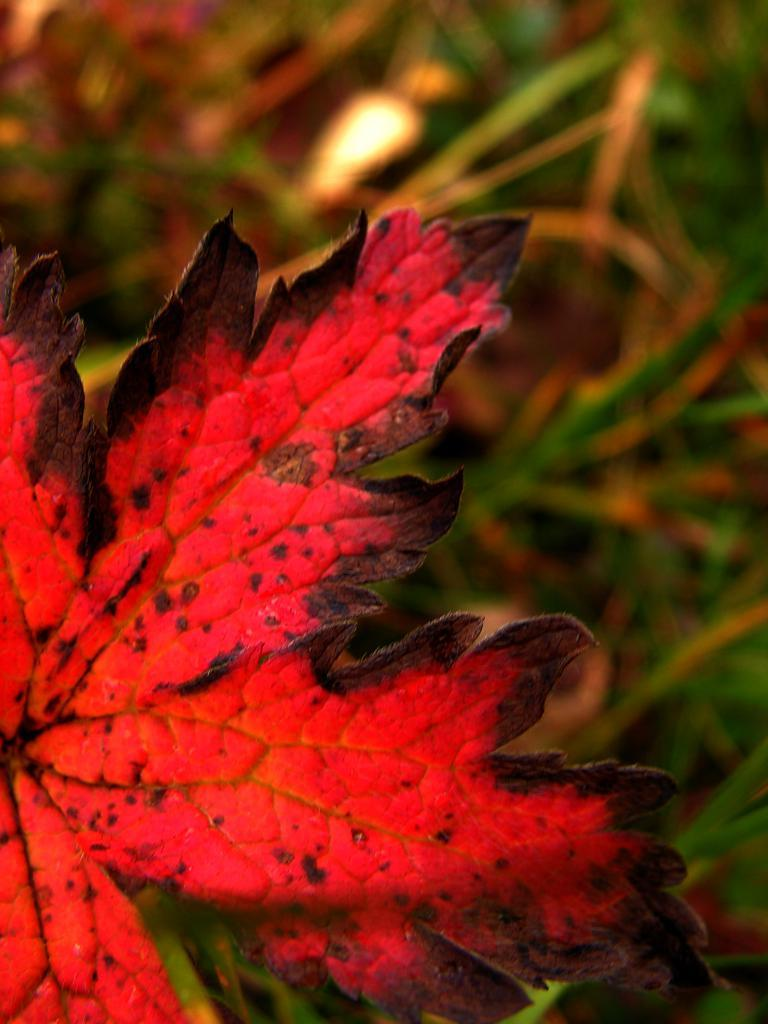What color is the leaf in the image? The leaf in the image is red and black. How is the background of the leaf depicted in the image? The background of the leaf is blurred. What type of earth is visible in the image? There is no earth visible in the image; it features a red and black leaf with a blurred background. What connection can be made between the leaf and a vacation in the image? There is no connection between the leaf and a vacation in the image, as it only shows a leaf with a blurred background. 